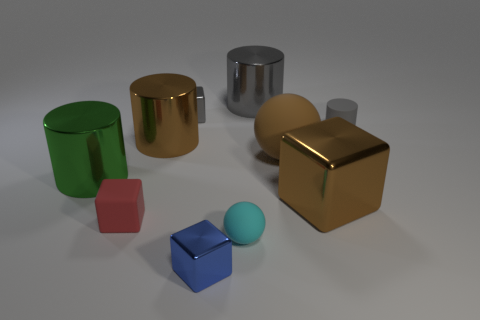Subtract all brown cylinders. How many cylinders are left? 3 Subtract all cyan cubes. Subtract all gray balls. How many cubes are left? 4 Subtract all cubes. How many objects are left? 6 Subtract all tiny brown rubber cylinders. Subtract all tiny red matte things. How many objects are left? 9 Add 4 big blocks. How many big blocks are left? 5 Add 6 big brown shiny things. How many big brown shiny things exist? 8 Subtract 1 red blocks. How many objects are left? 9 